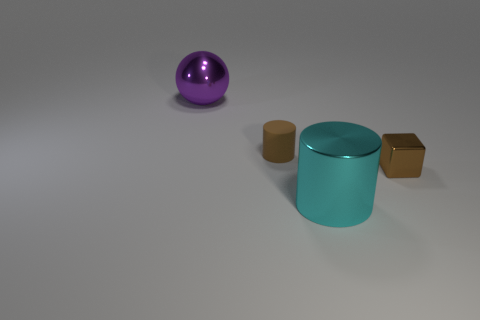Add 4 big cylinders. How many objects exist? 8 Subtract all purple cylinders. Subtract all cyan balls. How many cylinders are left? 2 Subtract all spheres. How many objects are left? 3 Subtract 0 cyan balls. How many objects are left? 4 Subtract all tiny rubber cylinders. Subtract all large metal things. How many objects are left? 1 Add 1 shiny cubes. How many shiny cubes are left? 2 Add 2 tiny brown metallic things. How many tiny brown metallic things exist? 3 